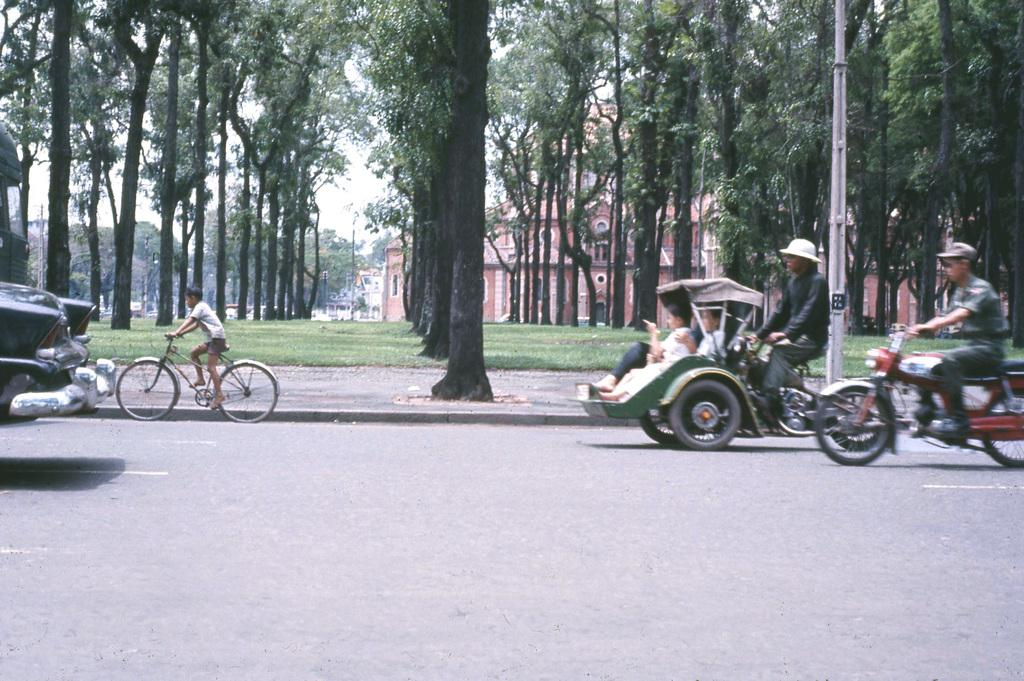What type of vehicle is in the image? There is a motorbike, a cart, a bicycle, and a car in the image. What are the vehicles doing in the image? The vehicles are moving on the road. What can be seen in the background of the image? There are trees and a building in the background of the image. What type of vegetable is being harvested in the image? There is no vegetable being harvested in the image; it features vehicles moving on the road. What kind of flower is growing near the building in the background? There is no flower visible in the image; only trees and a building can be seen in the background. 